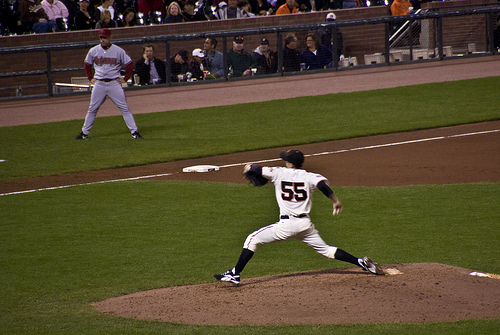Is the black hat on the pitcher that is on the mound? Yes, the black hat is on the pitcher who is standing on the mound. 